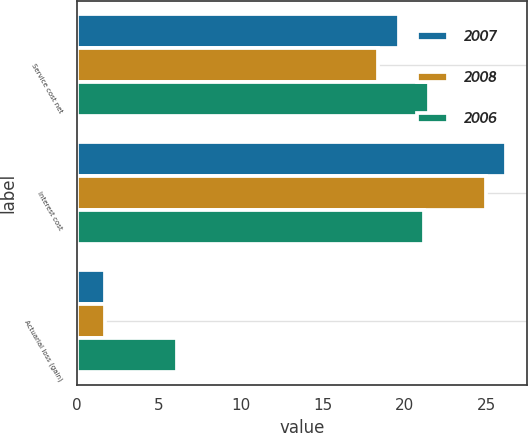Convert chart. <chart><loc_0><loc_0><loc_500><loc_500><stacked_bar_chart><ecel><fcel>Service cost net<fcel>Interest cost<fcel>Actuarial loss (gain)<nl><fcel>2007<fcel>19.7<fcel>26.2<fcel>1.7<nl><fcel>2008<fcel>18.4<fcel>25<fcel>1.7<nl><fcel>2006<fcel>21.5<fcel>21.2<fcel>6.1<nl></chart> 